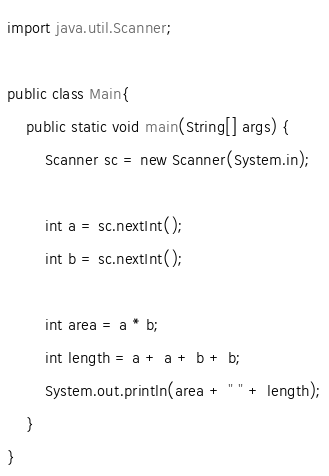Convert code to text. <code><loc_0><loc_0><loc_500><loc_500><_Java_>import java.util.Scanner;

public class Main{
	public static void main(String[] args) {
		Scanner sc = new Scanner(System.in);

		int a = sc.nextInt();
		int b = sc.nextInt();

		int area = a * b;
		int length = a + a + b + b;
		System.out.println(area + " " + length);
	}
}</code> 